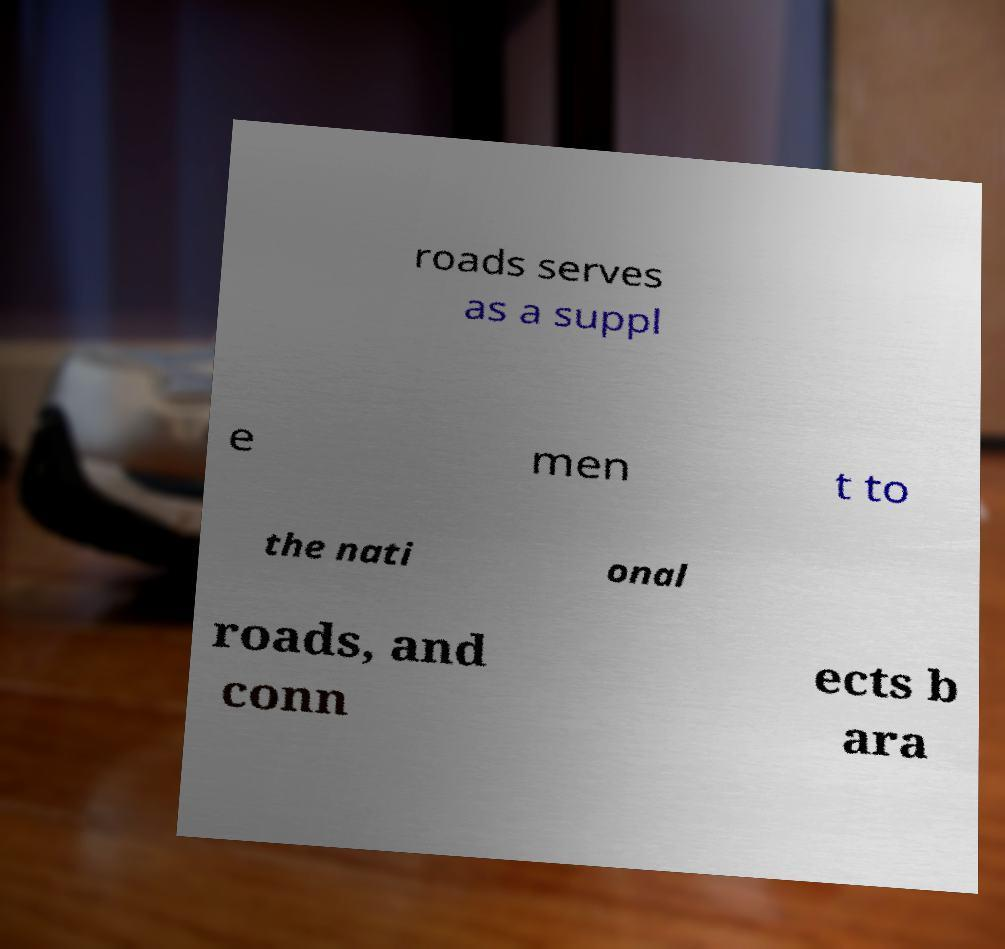What messages or text are displayed in this image? I need them in a readable, typed format. roads serves as a suppl e men t to the nati onal roads, and conn ects b ara 